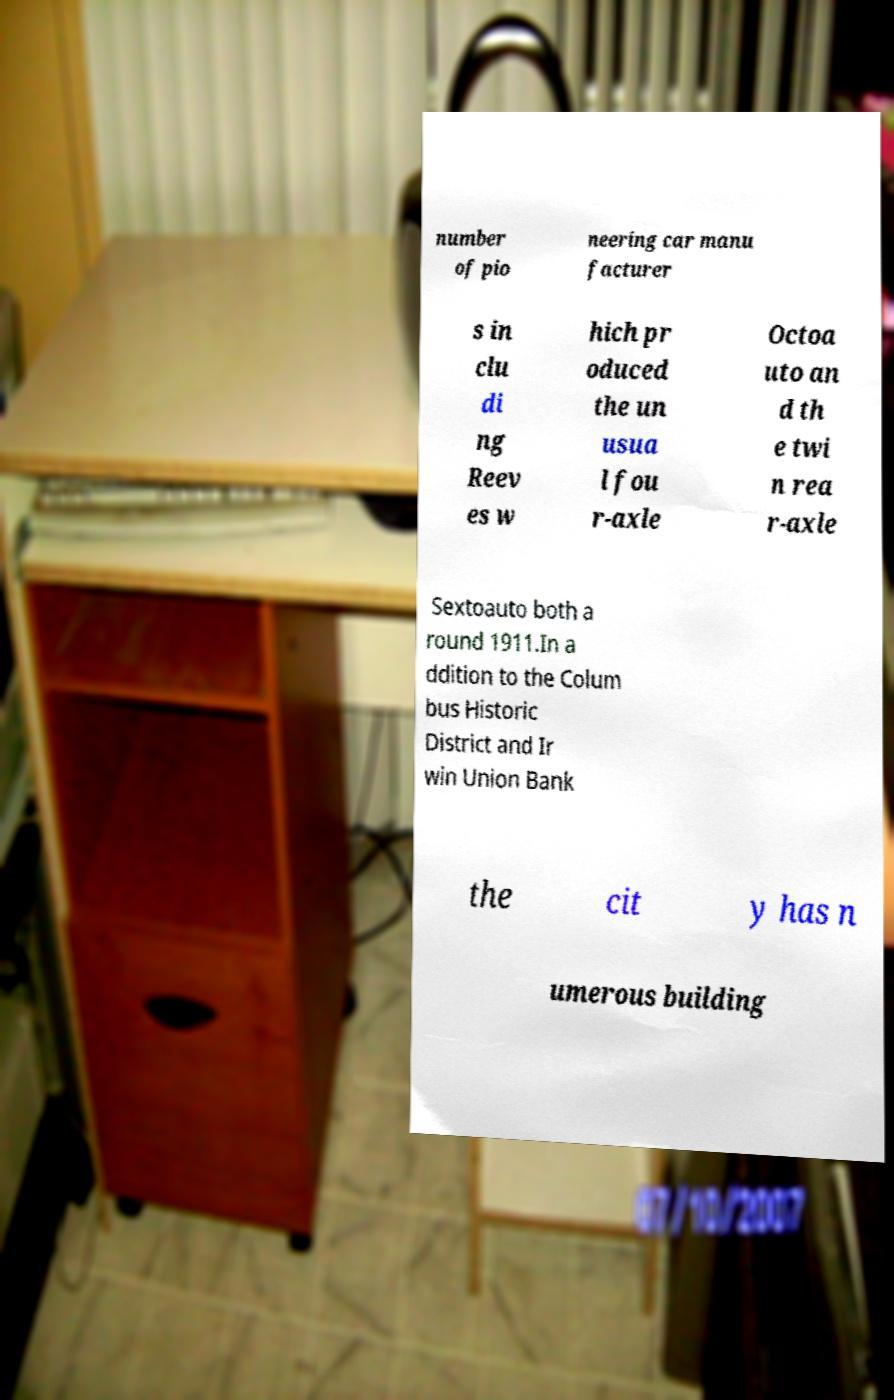Can you accurately transcribe the text from the provided image for me? number of pio neering car manu facturer s in clu di ng Reev es w hich pr oduced the un usua l fou r-axle Octoa uto an d th e twi n rea r-axle Sextoauto both a round 1911.In a ddition to the Colum bus Historic District and Ir win Union Bank the cit y has n umerous building 